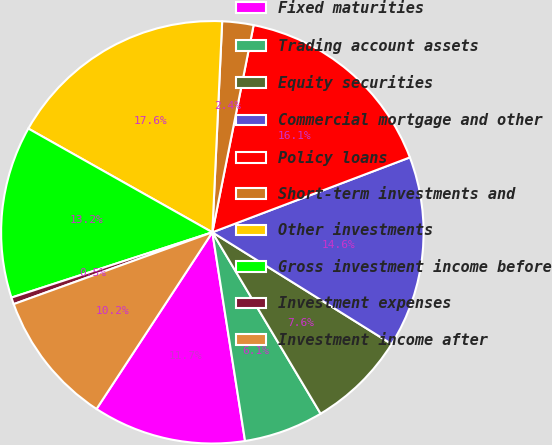Convert chart to OTSL. <chart><loc_0><loc_0><loc_500><loc_500><pie_chart><fcel>Fixed maturities<fcel>Trading account assets<fcel>Equity securities<fcel>Commercial mortgage and other<fcel>Policy loans<fcel>Short-term investments and<fcel>Other investments<fcel>Gross investment income before<fcel>Investment expenses<fcel>Investment income after<nl><fcel>11.71%<fcel>6.09%<fcel>7.56%<fcel>14.64%<fcel>16.1%<fcel>2.39%<fcel>17.57%<fcel>13.17%<fcel>0.52%<fcel>10.24%<nl></chart> 